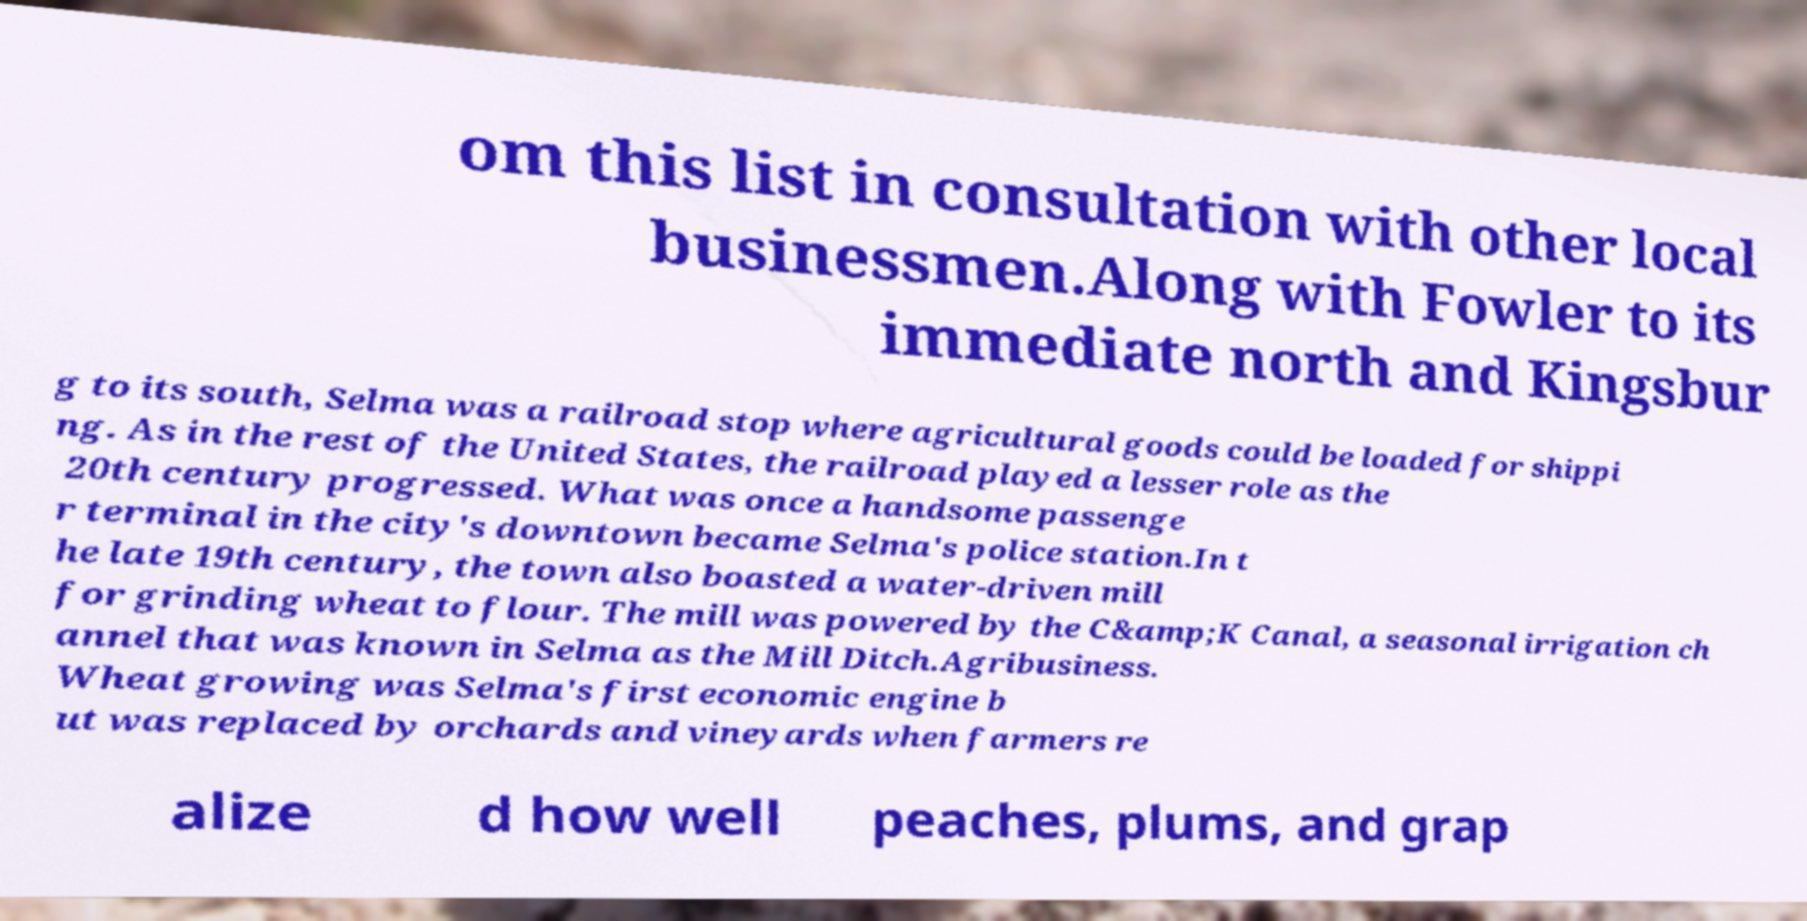Could you extract and type out the text from this image? om this list in consultation with other local businessmen.Along with Fowler to its immediate north and Kingsbur g to its south, Selma was a railroad stop where agricultural goods could be loaded for shippi ng. As in the rest of the United States, the railroad played a lesser role as the 20th century progressed. What was once a handsome passenge r terminal in the city's downtown became Selma's police station.In t he late 19th century, the town also boasted a water-driven mill for grinding wheat to flour. The mill was powered by the C&amp;K Canal, a seasonal irrigation ch annel that was known in Selma as the Mill Ditch.Agribusiness. Wheat growing was Selma's first economic engine b ut was replaced by orchards and vineyards when farmers re alize d how well peaches, plums, and grap 